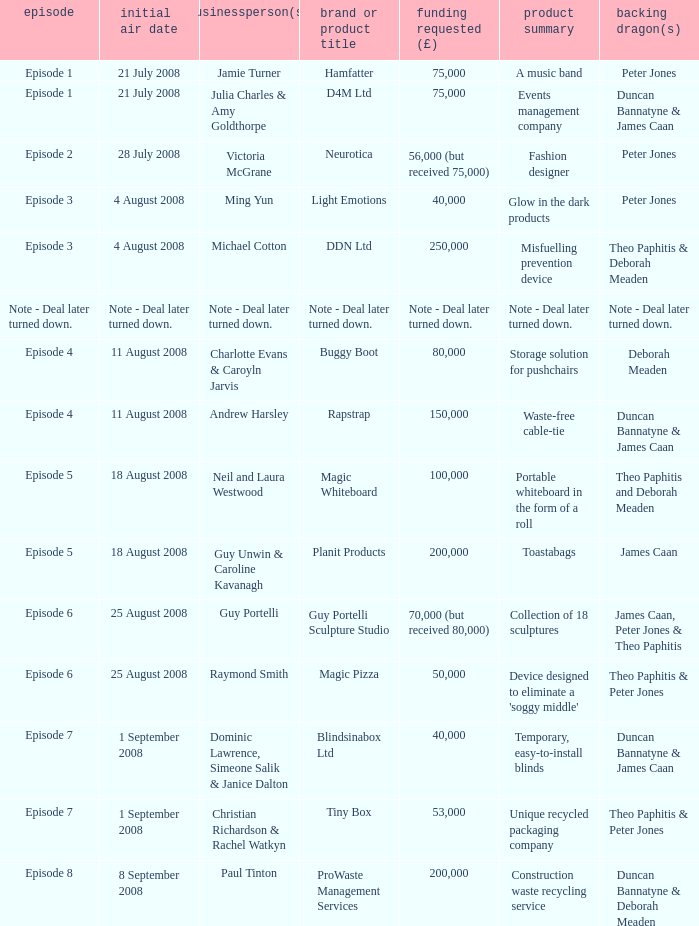When did episode 6 first air with entrepreneur Guy Portelli? 25 August 2008. 